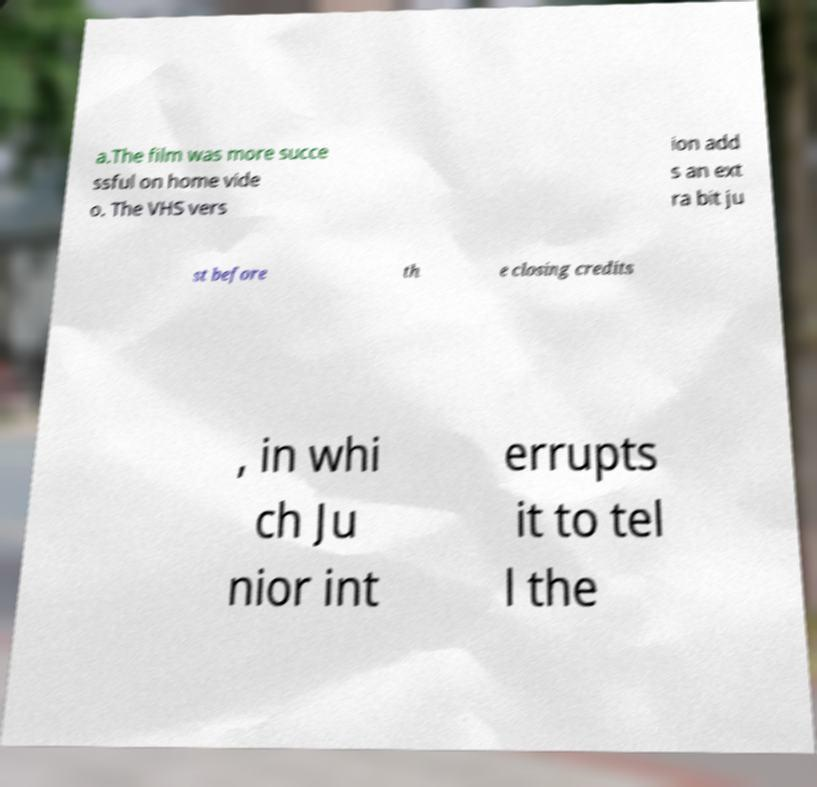Could you assist in decoding the text presented in this image and type it out clearly? a.The film was more succe ssful on home vide o. The VHS vers ion add s an ext ra bit ju st before th e closing credits , in whi ch Ju nior int errupts it to tel l the 